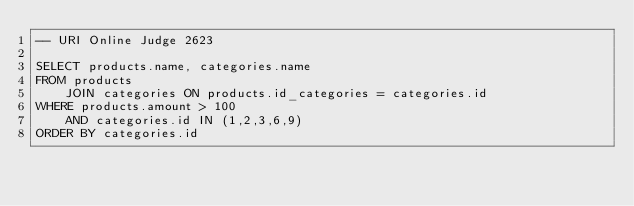<code> <loc_0><loc_0><loc_500><loc_500><_SQL_>-- URI Online Judge 2623

SELECT products.name, categories.name
FROM products
	JOIN categories ON products.id_categories = categories.id
WHERE products.amount > 100
	AND categories.id IN (1,2,3,6,9)
ORDER BY categories.id</code> 